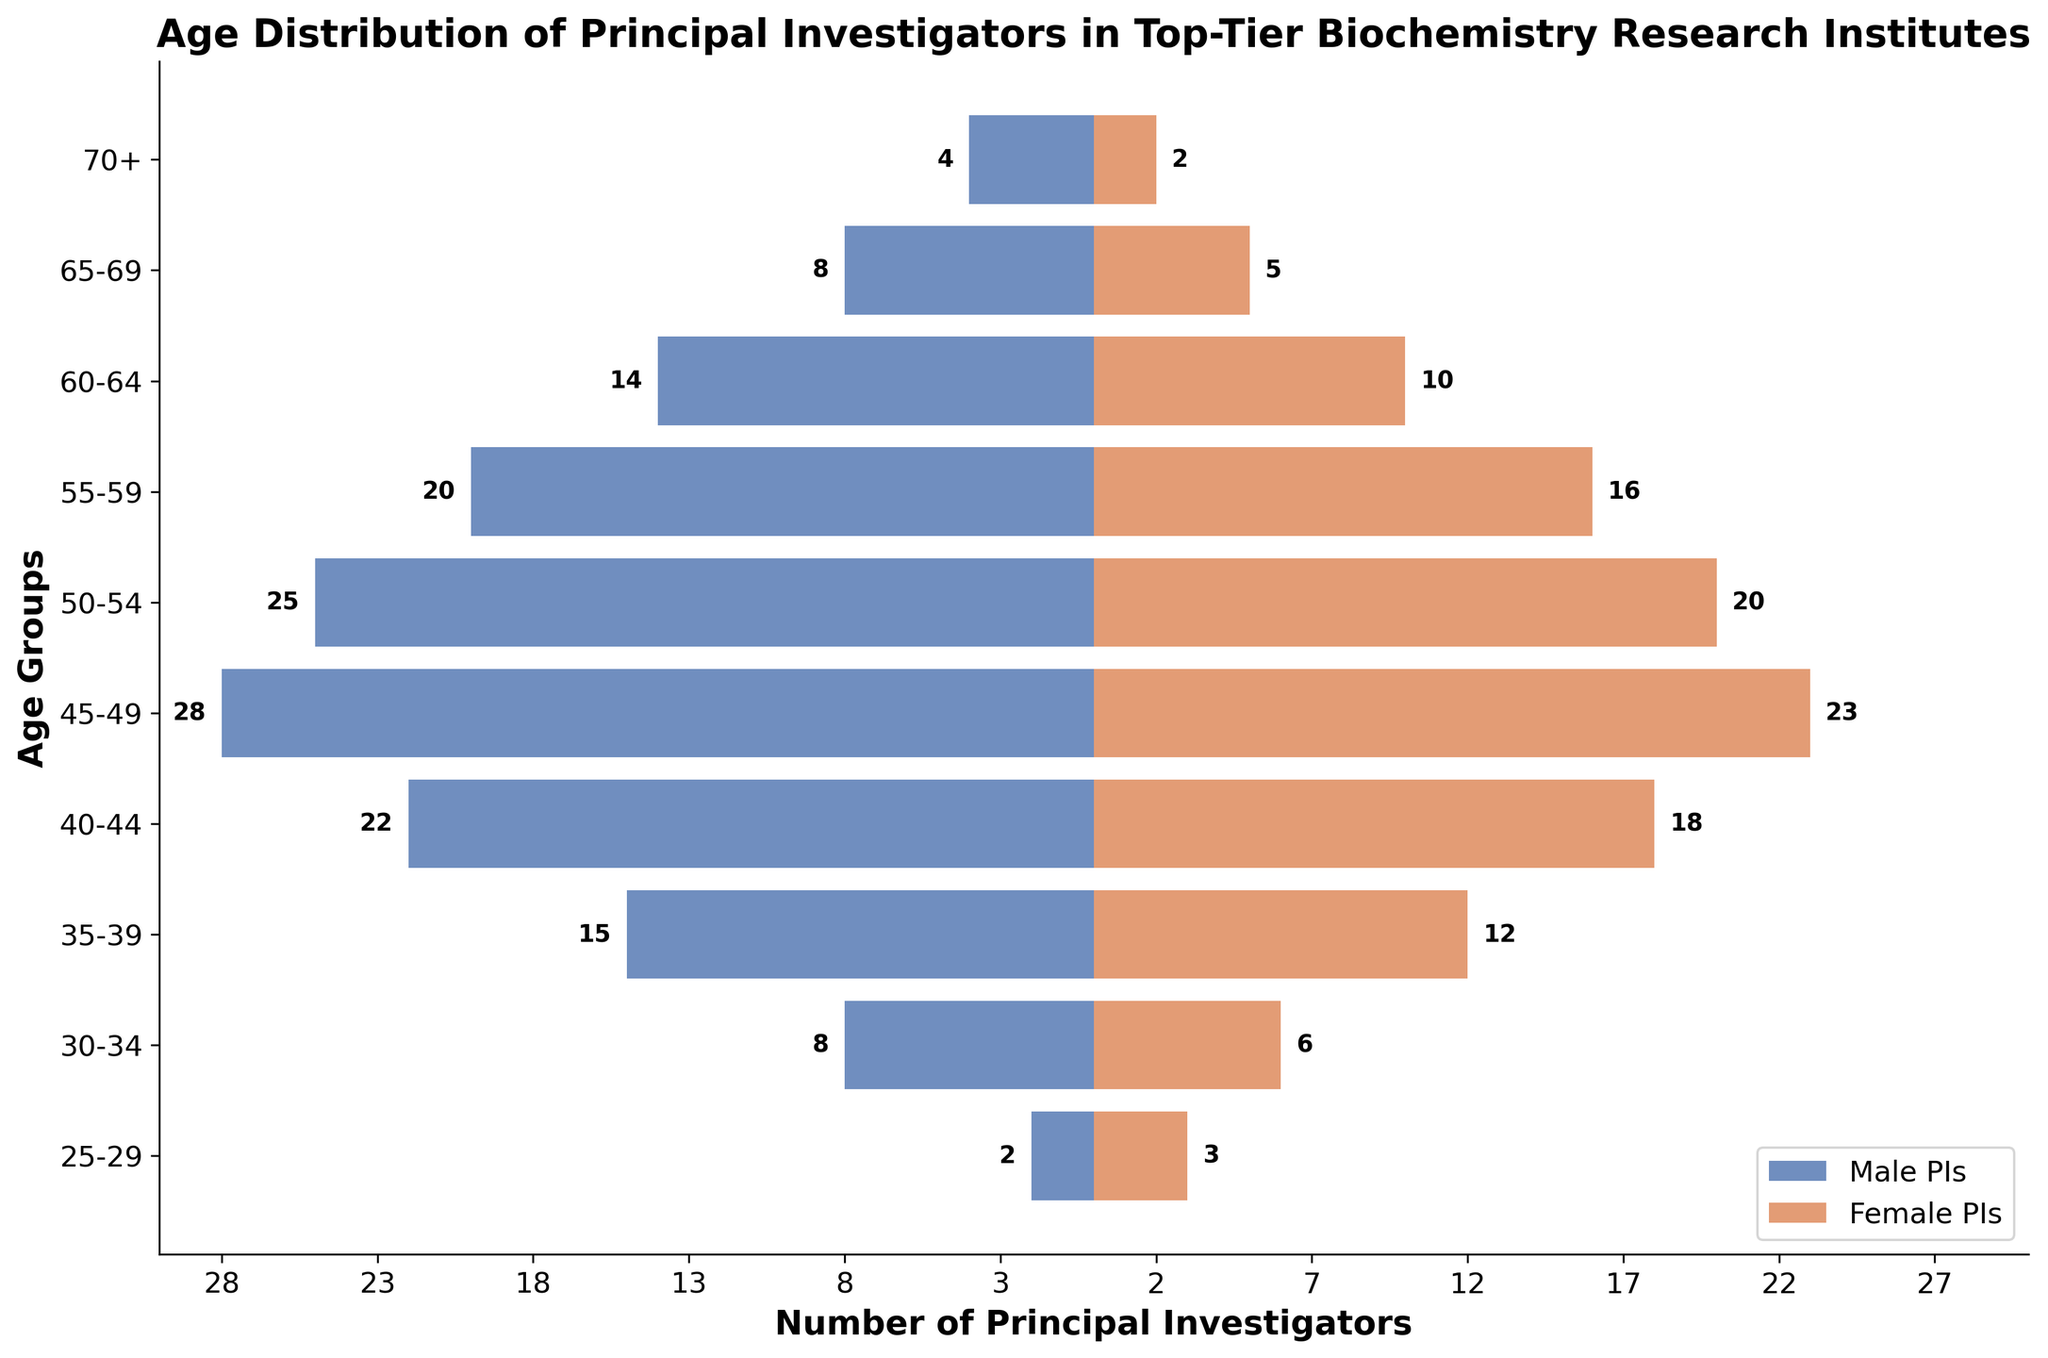What is the title of the population pyramid? The title is usually found at the top of the figure. From the information provided, the title is "Age Distribution of Principal Investigators in Top-Tier Biochemistry Research Institutes".
Answer: Age Distribution of Principal Investigators in Top-Tier Biochemistry Research Institutes What age group has the highest number of male PIs? To find this, look for the longest blue bar on the male side of the pyramid.
Answer: 45-49 Which age group has an equal number of male and female PIs? Compare the lengths of the blue and orange bars for each age group to see if they are the same length.
Answer: None How many age groups have more male PIs than female PIs? Count the age groups where the blue bar is longer than the orange bar.
Answer: 9 In the 55-59 age group, how many more male PIs are there compared to female PIs? Subtract the number of female PIs from the number of male PIs in the 55-59 age group (20 male - 16 female).
Answer: 4 What is the total number of female PIs aged 30-39? Add the number of female PIs in the 30-34 and 35-39 age groups (6 + 12).
Answer: 18 How does the number of female PIs in the 45-49 age group compare to that in the 50-54 age group? Compare the lengths of the orange bars for the 45-49 and 50-54 age groups (23 vs. 20).
Answer: 45-49 has more Which age group has the lowest total number of PIs (combining both male and female)? Add both male and female PIs for each age group and find the one with the smallest sum (4+2 = 6 for 70+).
Answer: 70+ What is the general trend in the number of PIs as the age increases? Observe the bars lengths from the youngest to the oldest age groups to determine if they increase, decrease, or remain constant.
Answer: Decrease How does the number of male PIs aged 60-64 compare to those aged 65-69? Compare the lengths of the blue bars for the 60-64 and 65-69 age groups (14 vs. 8).
Answer: 60-64 has more 